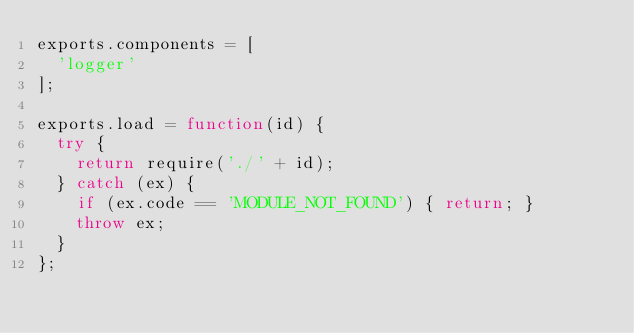<code> <loc_0><loc_0><loc_500><loc_500><_JavaScript_>exports.components = [
  'logger'
];

exports.load = function(id) {
  try {
    return require('./' + id);
  } catch (ex) {
    if (ex.code == 'MODULE_NOT_FOUND') { return; }
    throw ex;
  }
};
</code> 